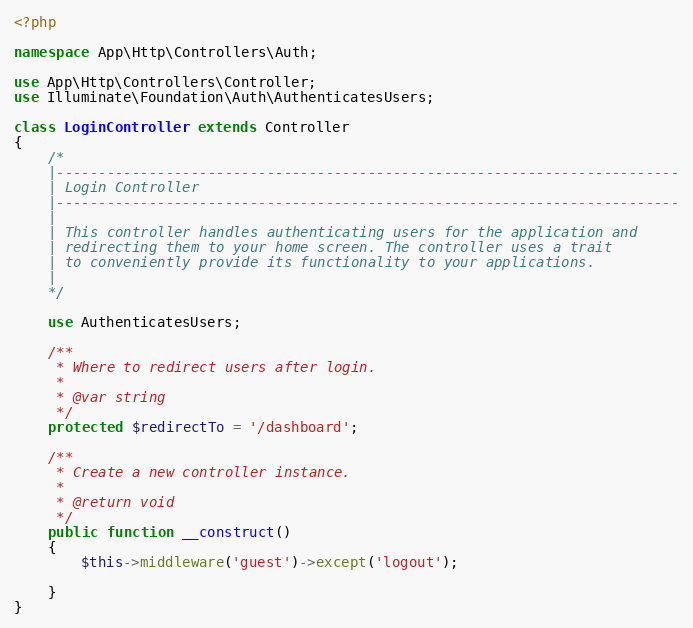<code> <loc_0><loc_0><loc_500><loc_500><_PHP_><?php

namespace App\Http\Controllers\Auth;

use App\Http\Controllers\Controller;
use Illuminate\Foundation\Auth\AuthenticatesUsers;

class LoginController extends Controller
{
    /*
    |--------------------------------------------------------------------------
    | Login Controller
    |--------------------------------------------------------------------------
    |
    | This controller handles authenticating users for the application and
    | redirecting them to your home screen. The controller uses a trait
    | to conveniently provide its functionality to your applications.
    |
    */

    use AuthenticatesUsers;

    /**
     * Where to redirect users after login.
     *
     * @var string
     */
    protected $redirectTo = '/dashboard';

    /**
     * Create a new controller instance.
     *
     * @return void
     */
    public function __construct()
    {
        $this->middleware('guest')->except('logout');
       
    }
}
</code> 